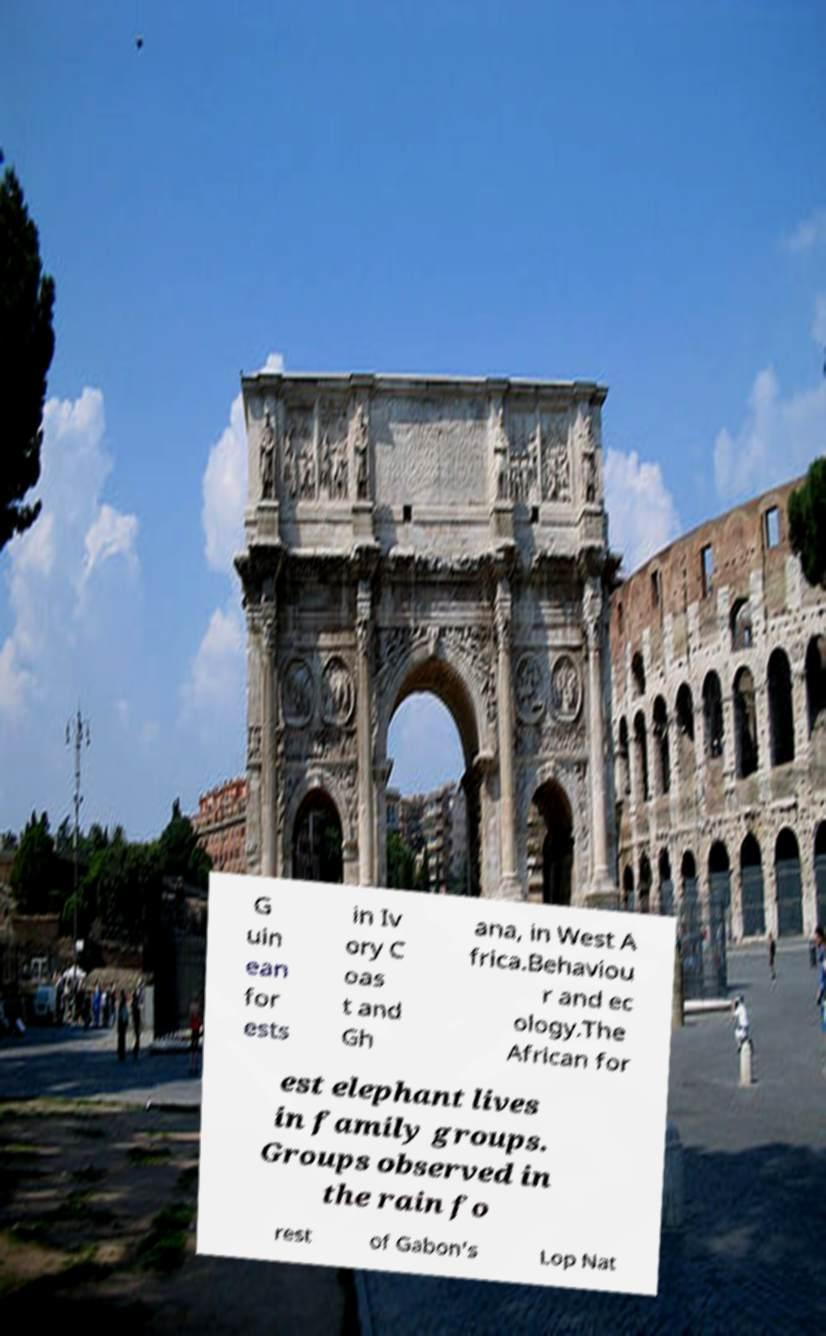Can you read and provide the text displayed in the image?This photo seems to have some interesting text. Can you extract and type it out for me? G uin ean for ests in Iv ory C oas t and Gh ana, in West A frica.Behaviou r and ec ology.The African for est elephant lives in family groups. Groups observed in the rain fo rest of Gabon's Lop Nat 